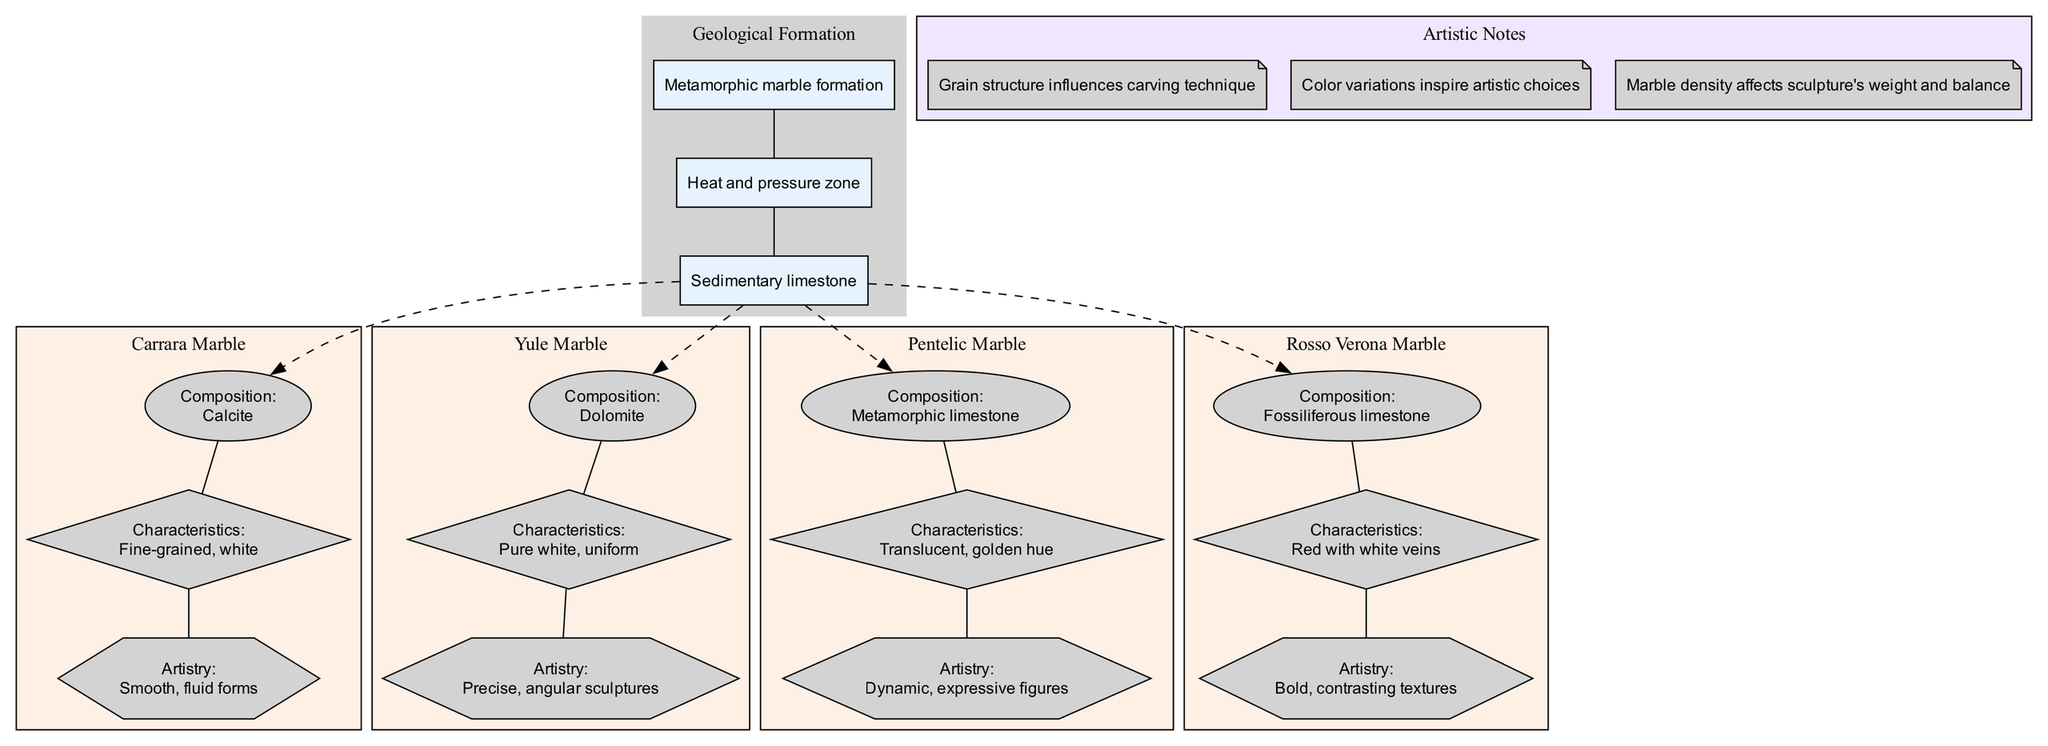What are the main components of Carrara Marble? Carrara Marble's composition is calcite, its characteristics are fine-grained and white, and it is known for its artistry in creating smooth, fluid forms. The components can be identified by looking at the specific nodes under the Carrara Marble subgraph in the diagram.
Answer: Calcite, fine-grained, white, smooth, fluid forms How many different types of marble are depicted in the diagram? The diagram shows four different types of marble, which can be counted based on the distinct marble nodes present in the diagram.
Answer: 4 What is the geological composition of Yule Marble? The composition of Yule Marble is dolomite, indicated in the node labeled for Yule Marble's composition. This can be confirmed by focusing on the Yule Marble subgraph in the diagram.
Answer: Dolomite Which marble type is noted for its precise, angular sculptures? Yule Marble is noted for its precise, angular sculptures, as indicated in the artistry of the Yule Marble node in the diagram.
Answer: Yule Marble What color attributes are associated with Rosso Verona Marble? Rosso Verona Marble is described as red with white veins. By examining the characteristics in the Rosso Verona Marble subgraph, this information can be directly retrieved.
Answer: Red with white veins How does marble density affect sculptures? The density of marble affects the sculpture's weight and balance; this information can be found in the artistic notes section of the diagram, highlighting the relationship between material properties and artistic execution.
Answer: Weight and balance What is the connection between geological layers and marble types? Each marble type is connected to the third geological layer labeled 'Metamorphic marble formation', which indicates that the types of marble depicted result from this specific geological process. The dashed edges in the diagram emphasize this connection.
Answer: Metamorphic marble formation What characteristics make Pentelic Marble dynamic and expressive? Pentelic Marble is characterized as translucent with a golden hue, which contributes to its dynamic and expressive figure artistry. This information is expressed at the characteristics and artistry nodes of Pentelic Marble in the diagram.
Answer: Translucent, golden hue 